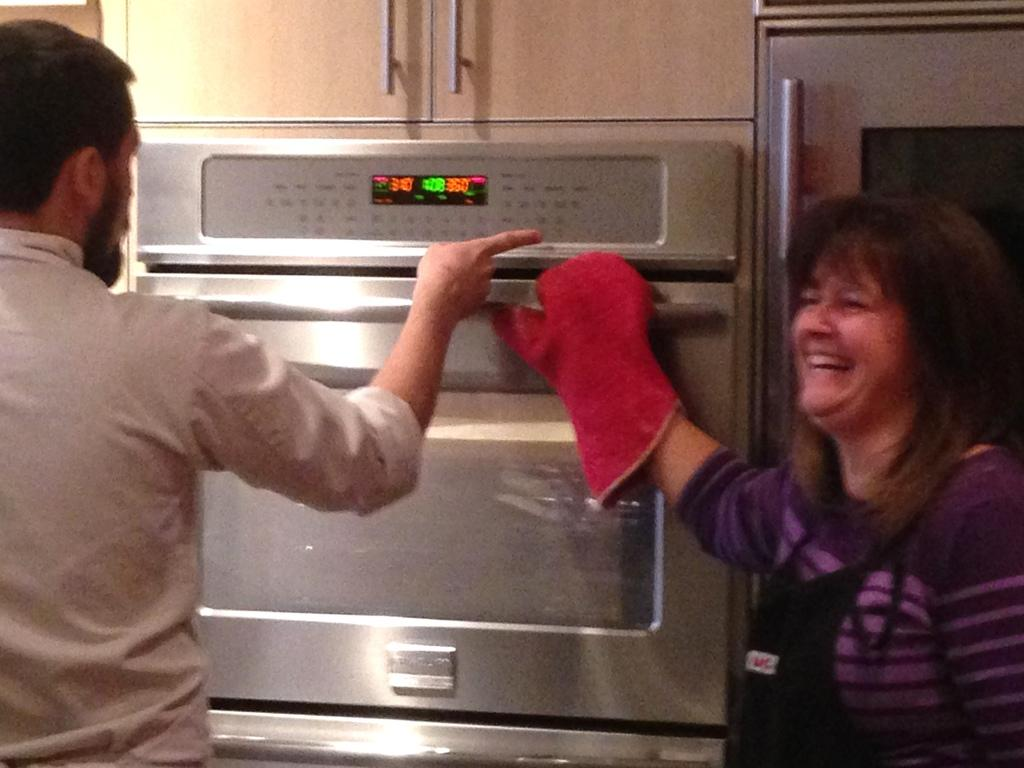Who are the people in the image? There is a woman and a man in the image. What are the positions of the woman and the man in the image? The woman is standing, and the man is standing. What object can be seen in the image that is typically used for heating food? There is a microwave oven in the image. How is the woman feeling in the image? The woman is smiling in the image. How many pigs are visible in the image? There are no pigs present in the image. What type of coil is being used by the man in the image? There is no coil visible in the image, and the man's actions are not described. 